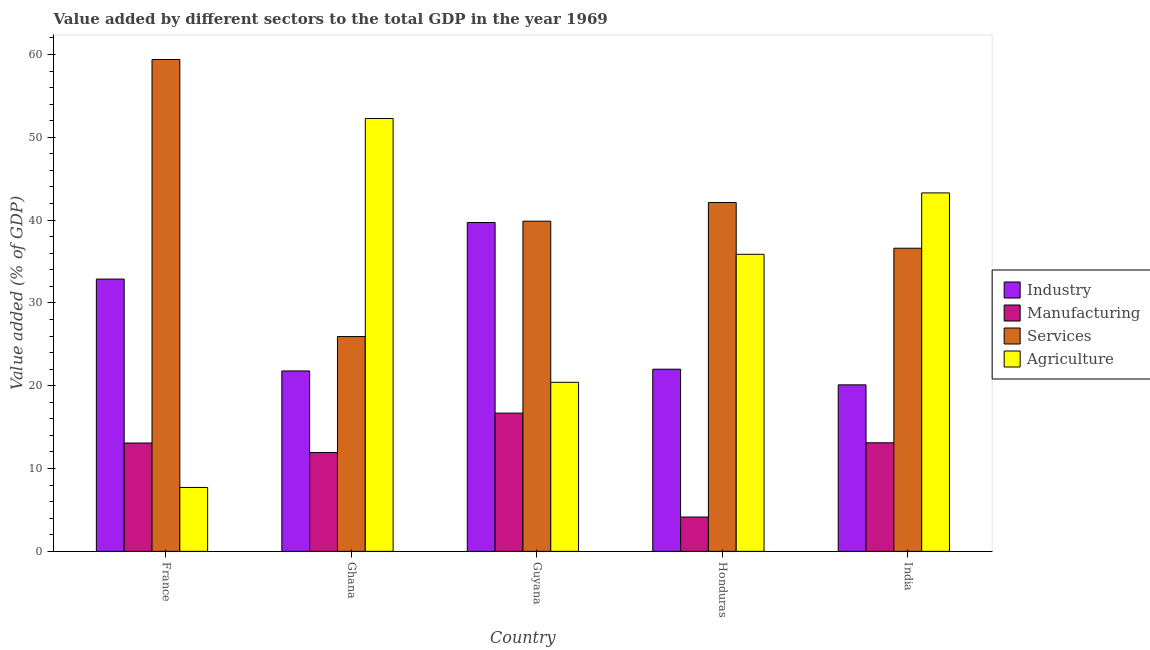How many groups of bars are there?
Offer a terse response. 5. Are the number of bars per tick equal to the number of legend labels?
Your answer should be very brief. Yes. Are the number of bars on each tick of the X-axis equal?
Provide a succinct answer. Yes. How many bars are there on the 4th tick from the left?
Ensure brevity in your answer.  4. How many bars are there on the 3rd tick from the right?
Provide a short and direct response. 4. What is the label of the 3rd group of bars from the left?
Your answer should be compact. Guyana. In how many cases, is the number of bars for a given country not equal to the number of legend labels?
Provide a short and direct response. 0. What is the value added by services sector in France?
Your answer should be very brief. 59.4. Across all countries, what is the maximum value added by industrial sector?
Give a very brief answer. 39.71. Across all countries, what is the minimum value added by agricultural sector?
Your answer should be very brief. 7.72. In which country was the value added by manufacturing sector maximum?
Offer a very short reply. Guyana. In which country was the value added by services sector minimum?
Provide a short and direct response. Ghana. What is the total value added by manufacturing sector in the graph?
Offer a very short reply. 58.97. What is the difference between the value added by agricultural sector in Ghana and that in Honduras?
Offer a very short reply. 16.4. What is the difference between the value added by services sector in Guyana and the value added by industrial sector in France?
Provide a short and direct response. 6.99. What is the average value added by agricultural sector per country?
Your answer should be compact. 31.91. What is the difference between the value added by agricultural sector and value added by services sector in Honduras?
Give a very brief answer. -6.26. In how many countries, is the value added by agricultural sector greater than 44 %?
Make the answer very short. 1. What is the ratio of the value added by manufacturing sector in Guyana to that in India?
Make the answer very short. 1.27. Is the value added by manufacturing sector in France less than that in Honduras?
Keep it short and to the point. No. Is the difference between the value added by agricultural sector in France and Ghana greater than the difference between the value added by services sector in France and Ghana?
Keep it short and to the point. No. What is the difference between the highest and the second highest value added by agricultural sector?
Provide a short and direct response. 8.99. What is the difference between the highest and the lowest value added by industrial sector?
Make the answer very short. 19.6. In how many countries, is the value added by industrial sector greater than the average value added by industrial sector taken over all countries?
Your response must be concise. 2. Is it the case that in every country, the sum of the value added by agricultural sector and value added by services sector is greater than the sum of value added by manufacturing sector and value added by industrial sector?
Ensure brevity in your answer.  No. What does the 4th bar from the left in India represents?
Make the answer very short. Agriculture. What does the 4th bar from the right in Honduras represents?
Give a very brief answer. Industry. How many countries are there in the graph?
Give a very brief answer. 5. What is the difference between two consecutive major ticks on the Y-axis?
Keep it short and to the point. 10. Does the graph contain grids?
Your answer should be very brief. No. What is the title of the graph?
Your answer should be compact. Value added by different sectors to the total GDP in the year 1969. What is the label or title of the X-axis?
Make the answer very short. Country. What is the label or title of the Y-axis?
Your answer should be very brief. Value added (% of GDP). What is the Value added (% of GDP) of Industry in France?
Offer a terse response. 32.88. What is the Value added (% of GDP) in Manufacturing in France?
Ensure brevity in your answer.  13.08. What is the Value added (% of GDP) in Services in France?
Provide a succinct answer. 59.4. What is the Value added (% of GDP) in Agriculture in France?
Provide a short and direct response. 7.72. What is the Value added (% of GDP) in Industry in Ghana?
Ensure brevity in your answer.  21.79. What is the Value added (% of GDP) in Manufacturing in Ghana?
Keep it short and to the point. 11.93. What is the Value added (% of GDP) in Services in Ghana?
Make the answer very short. 25.94. What is the Value added (% of GDP) in Agriculture in Ghana?
Offer a very short reply. 52.28. What is the Value added (% of GDP) in Industry in Guyana?
Give a very brief answer. 39.71. What is the Value added (% of GDP) in Manufacturing in Guyana?
Your response must be concise. 16.69. What is the Value added (% of GDP) in Services in Guyana?
Your response must be concise. 39.87. What is the Value added (% of GDP) in Agriculture in Guyana?
Ensure brevity in your answer.  20.42. What is the Value added (% of GDP) of Industry in Honduras?
Ensure brevity in your answer.  22. What is the Value added (% of GDP) of Manufacturing in Honduras?
Ensure brevity in your answer.  4.15. What is the Value added (% of GDP) of Services in Honduras?
Your answer should be very brief. 42.13. What is the Value added (% of GDP) in Agriculture in Honduras?
Provide a short and direct response. 35.87. What is the Value added (% of GDP) of Industry in India?
Make the answer very short. 20.11. What is the Value added (% of GDP) of Manufacturing in India?
Provide a succinct answer. 13.11. What is the Value added (% of GDP) in Services in India?
Offer a very short reply. 36.61. What is the Value added (% of GDP) in Agriculture in India?
Your answer should be compact. 43.29. Across all countries, what is the maximum Value added (% of GDP) of Industry?
Offer a terse response. 39.71. Across all countries, what is the maximum Value added (% of GDP) of Manufacturing?
Offer a terse response. 16.69. Across all countries, what is the maximum Value added (% of GDP) in Services?
Ensure brevity in your answer.  59.4. Across all countries, what is the maximum Value added (% of GDP) in Agriculture?
Ensure brevity in your answer.  52.28. Across all countries, what is the minimum Value added (% of GDP) of Industry?
Ensure brevity in your answer.  20.11. Across all countries, what is the minimum Value added (% of GDP) of Manufacturing?
Your answer should be compact. 4.15. Across all countries, what is the minimum Value added (% of GDP) in Services?
Keep it short and to the point. 25.94. Across all countries, what is the minimum Value added (% of GDP) in Agriculture?
Offer a very short reply. 7.72. What is the total Value added (% of GDP) in Industry in the graph?
Offer a terse response. 136.49. What is the total Value added (% of GDP) in Manufacturing in the graph?
Provide a short and direct response. 58.97. What is the total Value added (% of GDP) in Services in the graph?
Make the answer very short. 203.95. What is the total Value added (% of GDP) in Agriculture in the graph?
Offer a terse response. 159.57. What is the difference between the Value added (% of GDP) of Industry in France and that in Ghana?
Keep it short and to the point. 11.1. What is the difference between the Value added (% of GDP) in Manufacturing in France and that in Ghana?
Offer a very short reply. 1.15. What is the difference between the Value added (% of GDP) in Services in France and that in Ghana?
Provide a short and direct response. 33.46. What is the difference between the Value added (% of GDP) of Agriculture in France and that in Ghana?
Ensure brevity in your answer.  -44.56. What is the difference between the Value added (% of GDP) in Industry in France and that in Guyana?
Your response must be concise. -6.83. What is the difference between the Value added (% of GDP) of Manufacturing in France and that in Guyana?
Give a very brief answer. -3.61. What is the difference between the Value added (% of GDP) of Services in France and that in Guyana?
Make the answer very short. 19.53. What is the difference between the Value added (% of GDP) in Agriculture in France and that in Guyana?
Offer a terse response. -12.7. What is the difference between the Value added (% of GDP) in Industry in France and that in Honduras?
Offer a terse response. 10.88. What is the difference between the Value added (% of GDP) of Manufacturing in France and that in Honduras?
Give a very brief answer. 8.94. What is the difference between the Value added (% of GDP) in Services in France and that in Honduras?
Make the answer very short. 17.27. What is the difference between the Value added (% of GDP) of Agriculture in France and that in Honduras?
Your response must be concise. -28.15. What is the difference between the Value added (% of GDP) of Industry in France and that in India?
Your answer should be very brief. 12.77. What is the difference between the Value added (% of GDP) in Manufacturing in France and that in India?
Provide a succinct answer. -0.03. What is the difference between the Value added (% of GDP) in Services in France and that in India?
Your response must be concise. 22.79. What is the difference between the Value added (% of GDP) in Agriculture in France and that in India?
Make the answer very short. -35.57. What is the difference between the Value added (% of GDP) of Industry in Ghana and that in Guyana?
Provide a short and direct response. -17.93. What is the difference between the Value added (% of GDP) in Manufacturing in Ghana and that in Guyana?
Ensure brevity in your answer.  -4.76. What is the difference between the Value added (% of GDP) of Services in Ghana and that in Guyana?
Ensure brevity in your answer.  -13.93. What is the difference between the Value added (% of GDP) in Agriculture in Ghana and that in Guyana?
Make the answer very short. 31.86. What is the difference between the Value added (% of GDP) of Industry in Ghana and that in Honduras?
Give a very brief answer. -0.21. What is the difference between the Value added (% of GDP) in Manufacturing in Ghana and that in Honduras?
Make the answer very short. 7.79. What is the difference between the Value added (% of GDP) in Services in Ghana and that in Honduras?
Provide a succinct answer. -16.19. What is the difference between the Value added (% of GDP) in Agriculture in Ghana and that in Honduras?
Provide a succinct answer. 16.4. What is the difference between the Value added (% of GDP) of Industry in Ghana and that in India?
Ensure brevity in your answer.  1.68. What is the difference between the Value added (% of GDP) in Manufacturing in Ghana and that in India?
Offer a very short reply. -1.18. What is the difference between the Value added (% of GDP) in Services in Ghana and that in India?
Ensure brevity in your answer.  -10.67. What is the difference between the Value added (% of GDP) in Agriculture in Ghana and that in India?
Your answer should be very brief. 8.99. What is the difference between the Value added (% of GDP) of Industry in Guyana and that in Honduras?
Your response must be concise. 17.72. What is the difference between the Value added (% of GDP) in Manufacturing in Guyana and that in Honduras?
Ensure brevity in your answer.  12.55. What is the difference between the Value added (% of GDP) in Services in Guyana and that in Honduras?
Offer a terse response. -2.26. What is the difference between the Value added (% of GDP) in Agriculture in Guyana and that in Honduras?
Offer a very short reply. -15.46. What is the difference between the Value added (% of GDP) of Industry in Guyana and that in India?
Your response must be concise. 19.6. What is the difference between the Value added (% of GDP) in Manufacturing in Guyana and that in India?
Make the answer very short. 3.58. What is the difference between the Value added (% of GDP) in Services in Guyana and that in India?
Ensure brevity in your answer.  3.27. What is the difference between the Value added (% of GDP) of Agriculture in Guyana and that in India?
Offer a very short reply. -22.87. What is the difference between the Value added (% of GDP) in Industry in Honduras and that in India?
Make the answer very short. 1.89. What is the difference between the Value added (% of GDP) of Manufacturing in Honduras and that in India?
Offer a terse response. -8.96. What is the difference between the Value added (% of GDP) of Services in Honduras and that in India?
Offer a very short reply. 5.52. What is the difference between the Value added (% of GDP) of Agriculture in Honduras and that in India?
Offer a terse response. -7.41. What is the difference between the Value added (% of GDP) of Industry in France and the Value added (% of GDP) of Manufacturing in Ghana?
Your response must be concise. 20.95. What is the difference between the Value added (% of GDP) in Industry in France and the Value added (% of GDP) in Services in Ghana?
Make the answer very short. 6.94. What is the difference between the Value added (% of GDP) in Industry in France and the Value added (% of GDP) in Agriculture in Ghana?
Keep it short and to the point. -19.39. What is the difference between the Value added (% of GDP) of Manufacturing in France and the Value added (% of GDP) of Services in Ghana?
Offer a terse response. -12.86. What is the difference between the Value added (% of GDP) of Manufacturing in France and the Value added (% of GDP) of Agriculture in Ghana?
Offer a very short reply. -39.19. What is the difference between the Value added (% of GDP) of Services in France and the Value added (% of GDP) of Agriculture in Ghana?
Your response must be concise. 7.13. What is the difference between the Value added (% of GDP) of Industry in France and the Value added (% of GDP) of Manufacturing in Guyana?
Give a very brief answer. 16.19. What is the difference between the Value added (% of GDP) of Industry in France and the Value added (% of GDP) of Services in Guyana?
Provide a short and direct response. -6.99. What is the difference between the Value added (% of GDP) in Industry in France and the Value added (% of GDP) in Agriculture in Guyana?
Keep it short and to the point. 12.47. What is the difference between the Value added (% of GDP) of Manufacturing in France and the Value added (% of GDP) of Services in Guyana?
Ensure brevity in your answer.  -26.79. What is the difference between the Value added (% of GDP) of Manufacturing in France and the Value added (% of GDP) of Agriculture in Guyana?
Provide a short and direct response. -7.33. What is the difference between the Value added (% of GDP) in Services in France and the Value added (% of GDP) in Agriculture in Guyana?
Ensure brevity in your answer.  38.98. What is the difference between the Value added (% of GDP) of Industry in France and the Value added (% of GDP) of Manufacturing in Honduras?
Give a very brief answer. 28.74. What is the difference between the Value added (% of GDP) of Industry in France and the Value added (% of GDP) of Services in Honduras?
Keep it short and to the point. -9.25. What is the difference between the Value added (% of GDP) in Industry in France and the Value added (% of GDP) in Agriculture in Honduras?
Offer a very short reply. -2.99. What is the difference between the Value added (% of GDP) of Manufacturing in France and the Value added (% of GDP) of Services in Honduras?
Provide a succinct answer. -29.05. What is the difference between the Value added (% of GDP) of Manufacturing in France and the Value added (% of GDP) of Agriculture in Honduras?
Offer a terse response. -22.79. What is the difference between the Value added (% of GDP) in Services in France and the Value added (% of GDP) in Agriculture in Honduras?
Provide a short and direct response. 23.53. What is the difference between the Value added (% of GDP) in Industry in France and the Value added (% of GDP) in Manufacturing in India?
Your response must be concise. 19.77. What is the difference between the Value added (% of GDP) in Industry in France and the Value added (% of GDP) in Services in India?
Your answer should be very brief. -3.73. What is the difference between the Value added (% of GDP) in Industry in France and the Value added (% of GDP) in Agriculture in India?
Ensure brevity in your answer.  -10.4. What is the difference between the Value added (% of GDP) in Manufacturing in France and the Value added (% of GDP) in Services in India?
Your response must be concise. -23.52. What is the difference between the Value added (% of GDP) of Manufacturing in France and the Value added (% of GDP) of Agriculture in India?
Offer a very short reply. -30.2. What is the difference between the Value added (% of GDP) in Services in France and the Value added (% of GDP) in Agriculture in India?
Offer a terse response. 16.12. What is the difference between the Value added (% of GDP) of Industry in Ghana and the Value added (% of GDP) of Manufacturing in Guyana?
Your response must be concise. 5.09. What is the difference between the Value added (% of GDP) in Industry in Ghana and the Value added (% of GDP) in Services in Guyana?
Your answer should be very brief. -18.09. What is the difference between the Value added (% of GDP) in Industry in Ghana and the Value added (% of GDP) in Agriculture in Guyana?
Ensure brevity in your answer.  1.37. What is the difference between the Value added (% of GDP) in Manufacturing in Ghana and the Value added (% of GDP) in Services in Guyana?
Your answer should be very brief. -27.94. What is the difference between the Value added (% of GDP) of Manufacturing in Ghana and the Value added (% of GDP) of Agriculture in Guyana?
Give a very brief answer. -8.48. What is the difference between the Value added (% of GDP) in Services in Ghana and the Value added (% of GDP) in Agriculture in Guyana?
Provide a succinct answer. 5.52. What is the difference between the Value added (% of GDP) in Industry in Ghana and the Value added (% of GDP) in Manufacturing in Honduras?
Make the answer very short. 17.64. What is the difference between the Value added (% of GDP) of Industry in Ghana and the Value added (% of GDP) of Services in Honduras?
Make the answer very short. -20.35. What is the difference between the Value added (% of GDP) in Industry in Ghana and the Value added (% of GDP) in Agriculture in Honduras?
Your answer should be compact. -14.09. What is the difference between the Value added (% of GDP) in Manufacturing in Ghana and the Value added (% of GDP) in Services in Honduras?
Ensure brevity in your answer.  -30.2. What is the difference between the Value added (% of GDP) in Manufacturing in Ghana and the Value added (% of GDP) in Agriculture in Honduras?
Offer a very short reply. -23.94. What is the difference between the Value added (% of GDP) in Services in Ghana and the Value added (% of GDP) in Agriculture in Honduras?
Make the answer very short. -9.93. What is the difference between the Value added (% of GDP) of Industry in Ghana and the Value added (% of GDP) of Manufacturing in India?
Offer a terse response. 8.68. What is the difference between the Value added (% of GDP) in Industry in Ghana and the Value added (% of GDP) in Services in India?
Offer a very short reply. -14.82. What is the difference between the Value added (% of GDP) in Industry in Ghana and the Value added (% of GDP) in Agriculture in India?
Offer a very short reply. -21.5. What is the difference between the Value added (% of GDP) of Manufacturing in Ghana and the Value added (% of GDP) of Services in India?
Provide a short and direct response. -24.67. What is the difference between the Value added (% of GDP) of Manufacturing in Ghana and the Value added (% of GDP) of Agriculture in India?
Your answer should be very brief. -31.35. What is the difference between the Value added (% of GDP) of Services in Ghana and the Value added (% of GDP) of Agriculture in India?
Your answer should be compact. -17.35. What is the difference between the Value added (% of GDP) in Industry in Guyana and the Value added (% of GDP) in Manufacturing in Honduras?
Keep it short and to the point. 35.57. What is the difference between the Value added (% of GDP) of Industry in Guyana and the Value added (% of GDP) of Services in Honduras?
Your answer should be compact. -2.42. What is the difference between the Value added (% of GDP) of Industry in Guyana and the Value added (% of GDP) of Agriculture in Honduras?
Ensure brevity in your answer.  3.84. What is the difference between the Value added (% of GDP) in Manufacturing in Guyana and the Value added (% of GDP) in Services in Honduras?
Your answer should be compact. -25.44. What is the difference between the Value added (% of GDP) of Manufacturing in Guyana and the Value added (% of GDP) of Agriculture in Honduras?
Ensure brevity in your answer.  -19.18. What is the difference between the Value added (% of GDP) in Services in Guyana and the Value added (% of GDP) in Agriculture in Honduras?
Offer a very short reply. 4. What is the difference between the Value added (% of GDP) in Industry in Guyana and the Value added (% of GDP) in Manufacturing in India?
Provide a succinct answer. 26.6. What is the difference between the Value added (% of GDP) of Industry in Guyana and the Value added (% of GDP) of Services in India?
Ensure brevity in your answer.  3.11. What is the difference between the Value added (% of GDP) in Industry in Guyana and the Value added (% of GDP) in Agriculture in India?
Provide a succinct answer. -3.57. What is the difference between the Value added (% of GDP) of Manufacturing in Guyana and the Value added (% of GDP) of Services in India?
Offer a very short reply. -19.91. What is the difference between the Value added (% of GDP) in Manufacturing in Guyana and the Value added (% of GDP) in Agriculture in India?
Make the answer very short. -26.59. What is the difference between the Value added (% of GDP) of Services in Guyana and the Value added (% of GDP) of Agriculture in India?
Your answer should be very brief. -3.41. What is the difference between the Value added (% of GDP) of Industry in Honduras and the Value added (% of GDP) of Manufacturing in India?
Provide a succinct answer. 8.89. What is the difference between the Value added (% of GDP) of Industry in Honduras and the Value added (% of GDP) of Services in India?
Offer a terse response. -14.61. What is the difference between the Value added (% of GDP) of Industry in Honduras and the Value added (% of GDP) of Agriculture in India?
Give a very brief answer. -21.29. What is the difference between the Value added (% of GDP) of Manufacturing in Honduras and the Value added (% of GDP) of Services in India?
Offer a terse response. -32.46. What is the difference between the Value added (% of GDP) of Manufacturing in Honduras and the Value added (% of GDP) of Agriculture in India?
Keep it short and to the point. -39.14. What is the difference between the Value added (% of GDP) of Services in Honduras and the Value added (% of GDP) of Agriculture in India?
Keep it short and to the point. -1.15. What is the average Value added (% of GDP) of Industry per country?
Keep it short and to the point. 27.3. What is the average Value added (% of GDP) of Manufacturing per country?
Keep it short and to the point. 11.79. What is the average Value added (% of GDP) of Services per country?
Ensure brevity in your answer.  40.79. What is the average Value added (% of GDP) in Agriculture per country?
Provide a short and direct response. 31.91. What is the difference between the Value added (% of GDP) in Industry and Value added (% of GDP) in Manufacturing in France?
Your answer should be compact. 19.8. What is the difference between the Value added (% of GDP) in Industry and Value added (% of GDP) in Services in France?
Your answer should be very brief. -26.52. What is the difference between the Value added (% of GDP) in Industry and Value added (% of GDP) in Agriculture in France?
Give a very brief answer. 25.16. What is the difference between the Value added (% of GDP) in Manufacturing and Value added (% of GDP) in Services in France?
Offer a very short reply. -46.32. What is the difference between the Value added (% of GDP) of Manufacturing and Value added (% of GDP) of Agriculture in France?
Your answer should be very brief. 5.37. What is the difference between the Value added (% of GDP) of Services and Value added (% of GDP) of Agriculture in France?
Offer a very short reply. 51.68. What is the difference between the Value added (% of GDP) in Industry and Value added (% of GDP) in Manufacturing in Ghana?
Keep it short and to the point. 9.85. What is the difference between the Value added (% of GDP) in Industry and Value added (% of GDP) in Services in Ghana?
Offer a terse response. -4.15. What is the difference between the Value added (% of GDP) in Industry and Value added (% of GDP) in Agriculture in Ghana?
Keep it short and to the point. -30.49. What is the difference between the Value added (% of GDP) of Manufacturing and Value added (% of GDP) of Services in Ghana?
Give a very brief answer. -14.01. What is the difference between the Value added (% of GDP) of Manufacturing and Value added (% of GDP) of Agriculture in Ghana?
Offer a terse response. -40.34. What is the difference between the Value added (% of GDP) of Services and Value added (% of GDP) of Agriculture in Ghana?
Offer a terse response. -26.34. What is the difference between the Value added (% of GDP) of Industry and Value added (% of GDP) of Manufacturing in Guyana?
Your response must be concise. 23.02. What is the difference between the Value added (% of GDP) of Industry and Value added (% of GDP) of Services in Guyana?
Provide a succinct answer. -0.16. What is the difference between the Value added (% of GDP) of Industry and Value added (% of GDP) of Agriculture in Guyana?
Give a very brief answer. 19.3. What is the difference between the Value added (% of GDP) of Manufacturing and Value added (% of GDP) of Services in Guyana?
Your response must be concise. -23.18. What is the difference between the Value added (% of GDP) of Manufacturing and Value added (% of GDP) of Agriculture in Guyana?
Provide a succinct answer. -3.72. What is the difference between the Value added (% of GDP) in Services and Value added (% of GDP) in Agriculture in Guyana?
Provide a short and direct response. 19.46. What is the difference between the Value added (% of GDP) of Industry and Value added (% of GDP) of Manufacturing in Honduras?
Provide a short and direct response. 17.85. What is the difference between the Value added (% of GDP) of Industry and Value added (% of GDP) of Services in Honduras?
Provide a short and direct response. -20.13. What is the difference between the Value added (% of GDP) of Industry and Value added (% of GDP) of Agriculture in Honduras?
Give a very brief answer. -13.87. What is the difference between the Value added (% of GDP) of Manufacturing and Value added (% of GDP) of Services in Honduras?
Provide a short and direct response. -37.99. What is the difference between the Value added (% of GDP) of Manufacturing and Value added (% of GDP) of Agriculture in Honduras?
Offer a terse response. -31.73. What is the difference between the Value added (% of GDP) of Services and Value added (% of GDP) of Agriculture in Honduras?
Your answer should be very brief. 6.26. What is the difference between the Value added (% of GDP) of Industry and Value added (% of GDP) of Manufacturing in India?
Ensure brevity in your answer.  7. What is the difference between the Value added (% of GDP) of Industry and Value added (% of GDP) of Services in India?
Give a very brief answer. -16.5. What is the difference between the Value added (% of GDP) in Industry and Value added (% of GDP) in Agriculture in India?
Provide a succinct answer. -23.18. What is the difference between the Value added (% of GDP) of Manufacturing and Value added (% of GDP) of Services in India?
Keep it short and to the point. -23.5. What is the difference between the Value added (% of GDP) in Manufacturing and Value added (% of GDP) in Agriculture in India?
Make the answer very short. -30.17. What is the difference between the Value added (% of GDP) in Services and Value added (% of GDP) in Agriculture in India?
Keep it short and to the point. -6.68. What is the ratio of the Value added (% of GDP) in Industry in France to that in Ghana?
Give a very brief answer. 1.51. What is the ratio of the Value added (% of GDP) in Manufacturing in France to that in Ghana?
Keep it short and to the point. 1.1. What is the ratio of the Value added (% of GDP) of Services in France to that in Ghana?
Provide a succinct answer. 2.29. What is the ratio of the Value added (% of GDP) of Agriculture in France to that in Ghana?
Offer a terse response. 0.15. What is the ratio of the Value added (% of GDP) of Industry in France to that in Guyana?
Your response must be concise. 0.83. What is the ratio of the Value added (% of GDP) in Manufacturing in France to that in Guyana?
Your answer should be compact. 0.78. What is the ratio of the Value added (% of GDP) in Services in France to that in Guyana?
Keep it short and to the point. 1.49. What is the ratio of the Value added (% of GDP) in Agriculture in France to that in Guyana?
Keep it short and to the point. 0.38. What is the ratio of the Value added (% of GDP) in Industry in France to that in Honduras?
Your answer should be compact. 1.49. What is the ratio of the Value added (% of GDP) of Manufacturing in France to that in Honduras?
Provide a succinct answer. 3.16. What is the ratio of the Value added (% of GDP) of Services in France to that in Honduras?
Provide a short and direct response. 1.41. What is the ratio of the Value added (% of GDP) in Agriculture in France to that in Honduras?
Keep it short and to the point. 0.22. What is the ratio of the Value added (% of GDP) of Industry in France to that in India?
Offer a very short reply. 1.64. What is the ratio of the Value added (% of GDP) in Manufacturing in France to that in India?
Your answer should be compact. 1. What is the ratio of the Value added (% of GDP) in Services in France to that in India?
Offer a very short reply. 1.62. What is the ratio of the Value added (% of GDP) of Agriculture in France to that in India?
Provide a short and direct response. 0.18. What is the ratio of the Value added (% of GDP) of Industry in Ghana to that in Guyana?
Provide a short and direct response. 0.55. What is the ratio of the Value added (% of GDP) of Manufacturing in Ghana to that in Guyana?
Your answer should be very brief. 0.71. What is the ratio of the Value added (% of GDP) of Services in Ghana to that in Guyana?
Your answer should be very brief. 0.65. What is the ratio of the Value added (% of GDP) in Agriculture in Ghana to that in Guyana?
Your answer should be very brief. 2.56. What is the ratio of the Value added (% of GDP) in Manufacturing in Ghana to that in Honduras?
Make the answer very short. 2.88. What is the ratio of the Value added (% of GDP) in Services in Ghana to that in Honduras?
Keep it short and to the point. 0.62. What is the ratio of the Value added (% of GDP) in Agriculture in Ghana to that in Honduras?
Give a very brief answer. 1.46. What is the ratio of the Value added (% of GDP) in Industry in Ghana to that in India?
Offer a very short reply. 1.08. What is the ratio of the Value added (% of GDP) in Manufacturing in Ghana to that in India?
Keep it short and to the point. 0.91. What is the ratio of the Value added (% of GDP) in Services in Ghana to that in India?
Provide a succinct answer. 0.71. What is the ratio of the Value added (% of GDP) in Agriculture in Ghana to that in India?
Ensure brevity in your answer.  1.21. What is the ratio of the Value added (% of GDP) of Industry in Guyana to that in Honduras?
Provide a succinct answer. 1.81. What is the ratio of the Value added (% of GDP) in Manufacturing in Guyana to that in Honduras?
Provide a short and direct response. 4.03. What is the ratio of the Value added (% of GDP) in Services in Guyana to that in Honduras?
Your answer should be very brief. 0.95. What is the ratio of the Value added (% of GDP) in Agriculture in Guyana to that in Honduras?
Your response must be concise. 0.57. What is the ratio of the Value added (% of GDP) in Industry in Guyana to that in India?
Ensure brevity in your answer.  1.98. What is the ratio of the Value added (% of GDP) of Manufacturing in Guyana to that in India?
Your answer should be compact. 1.27. What is the ratio of the Value added (% of GDP) in Services in Guyana to that in India?
Your answer should be very brief. 1.09. What is the ratio of the Value added (% of GDP) in Agriculture in Guyana to that in India?
Offer a terse response. 0.47. What is the ratio of the Value added (% of GDP) in Industry in Honduras to that in India?
Provide a short and direct response. 1.09. What is the ratio of the Value added (% of GDP) of Manufacturing in Honduras to that in India?
Ensure brevity in your answer.  0.32. What is the ratio of the Value added (% of GDP) in Services in Honduras to that in India?
Provide a succinct answer. 1.15. What is the ratio of the Value added (% of GDP) in Agriculture in Honduras to that in India?
Your response must be concise. 0.83. What is the difference between the highest and the second highest Value added (% of GDP) of Industry?
Offer a terse response. 6.83. What is the difference between the highest and the second highest Value added (% of GDP) of Manufacturing?
Make the answer very short. 3.58. What is the difference between the highest and the second highest Value added (% of GDP) in Services?
Your answer should be compact. 17.27. What is the difference between the highest and the second highest Value added (% of GDP) of Agriculture?
Make the answer very short. 8.99. What is the difference between the highest and the lowest Value added (% of GDP) in Industry?
Your response must be concise. 19.6. What is the difference between the highest and the lowest Value added (% of GDP) of Manufacturing?
Your answer should be very brief. 12.55. What is the difference between the highest and the lowest Value added (% of GDP) of Services?
Your response must be concise. 33.46. What is the difference between the highest and the lowest Value added (% of GDP) in Agriculture?
Provide a succinct answer. 44.56. 